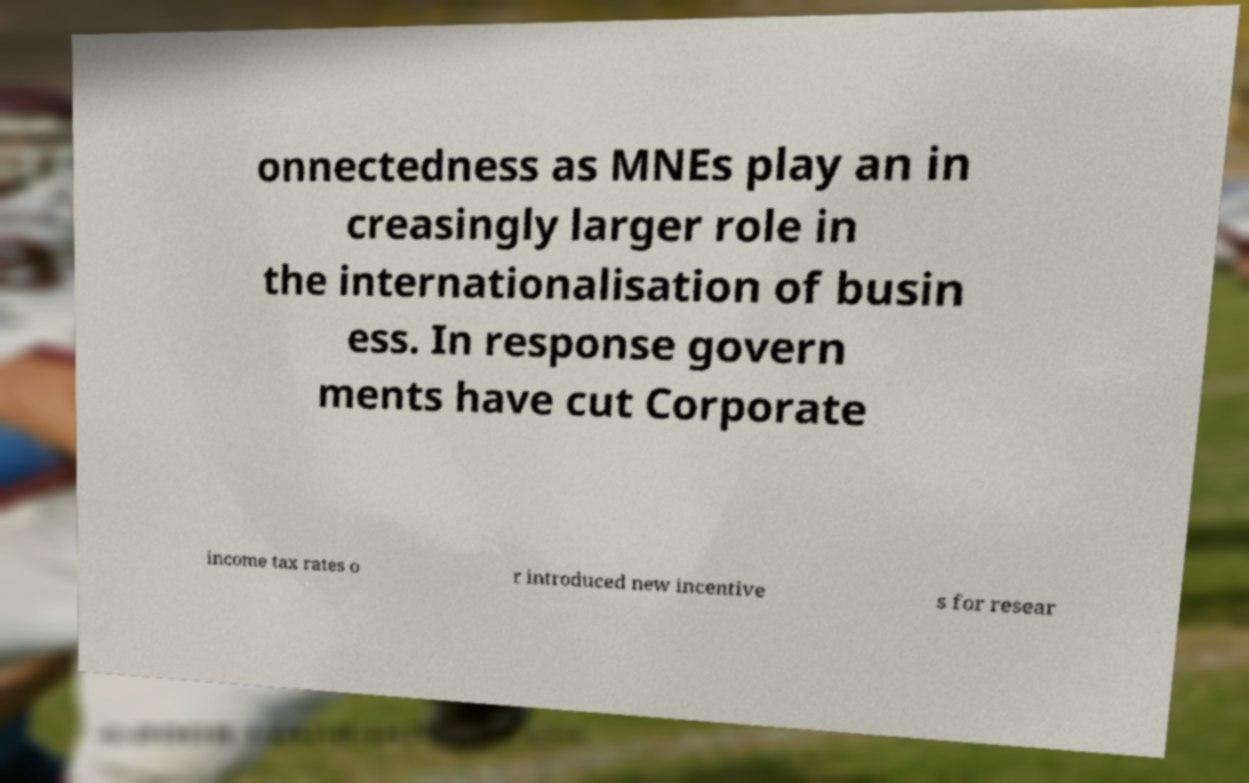Can you read and provide the text displayed in the image?This photo seems to have some interesting text. Can you extract and type it out for me? onnectedness as MNEs play an in creasingly larger role in the internationalisation of busin ess. In response govern ments have cut Corporate income tax rates o r introduced new incentive s for resear 